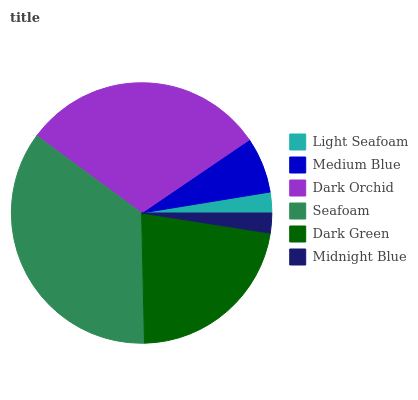Is Midnight Blue the minimum?
Answer yes or no. Yes. Is Seafoam the maximum?
Answer yes or no. Yes. Is Medium Blue the minimum?
Answer yes or no. No. Is Medium Blue the maximum?
Answer yes or no. No. Is Medium Blue greater than Light Seafoam?
Answer yes or no. Yes. Is Light Seafoam less than Medium Blue?
Answer yes or no. Yes. Is Light Seafoam greater than Medium Blue?
Answer yes or no. No. Is Medium Blue less than Light Seafoam?
Answer yes or no. No. Is Dark Green the high median?
Answer yes or no. Yes. Is Medium Blue the low median?
Answer yes or no. Yes. Is Medium Blue the high median?
Answer yes or no. No. Is Seafoam the low median?
Answer yes or no. No. 